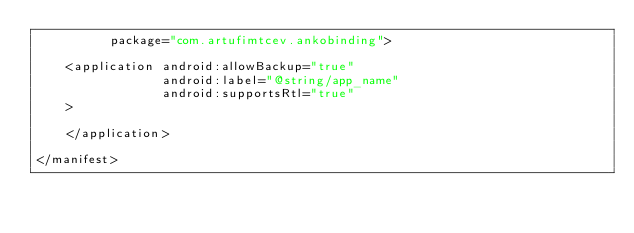Convert code to text. <code><loc_0><loc_0><loc_500><loc_500><_XML_>		  package="com.artufimtcev.ankobinding">

	<application android:allowBackup="true"
				 android:label="@string/app_name"
				 android:supportsRtl="true"
	>

	</application>

</manifest>
</code> 